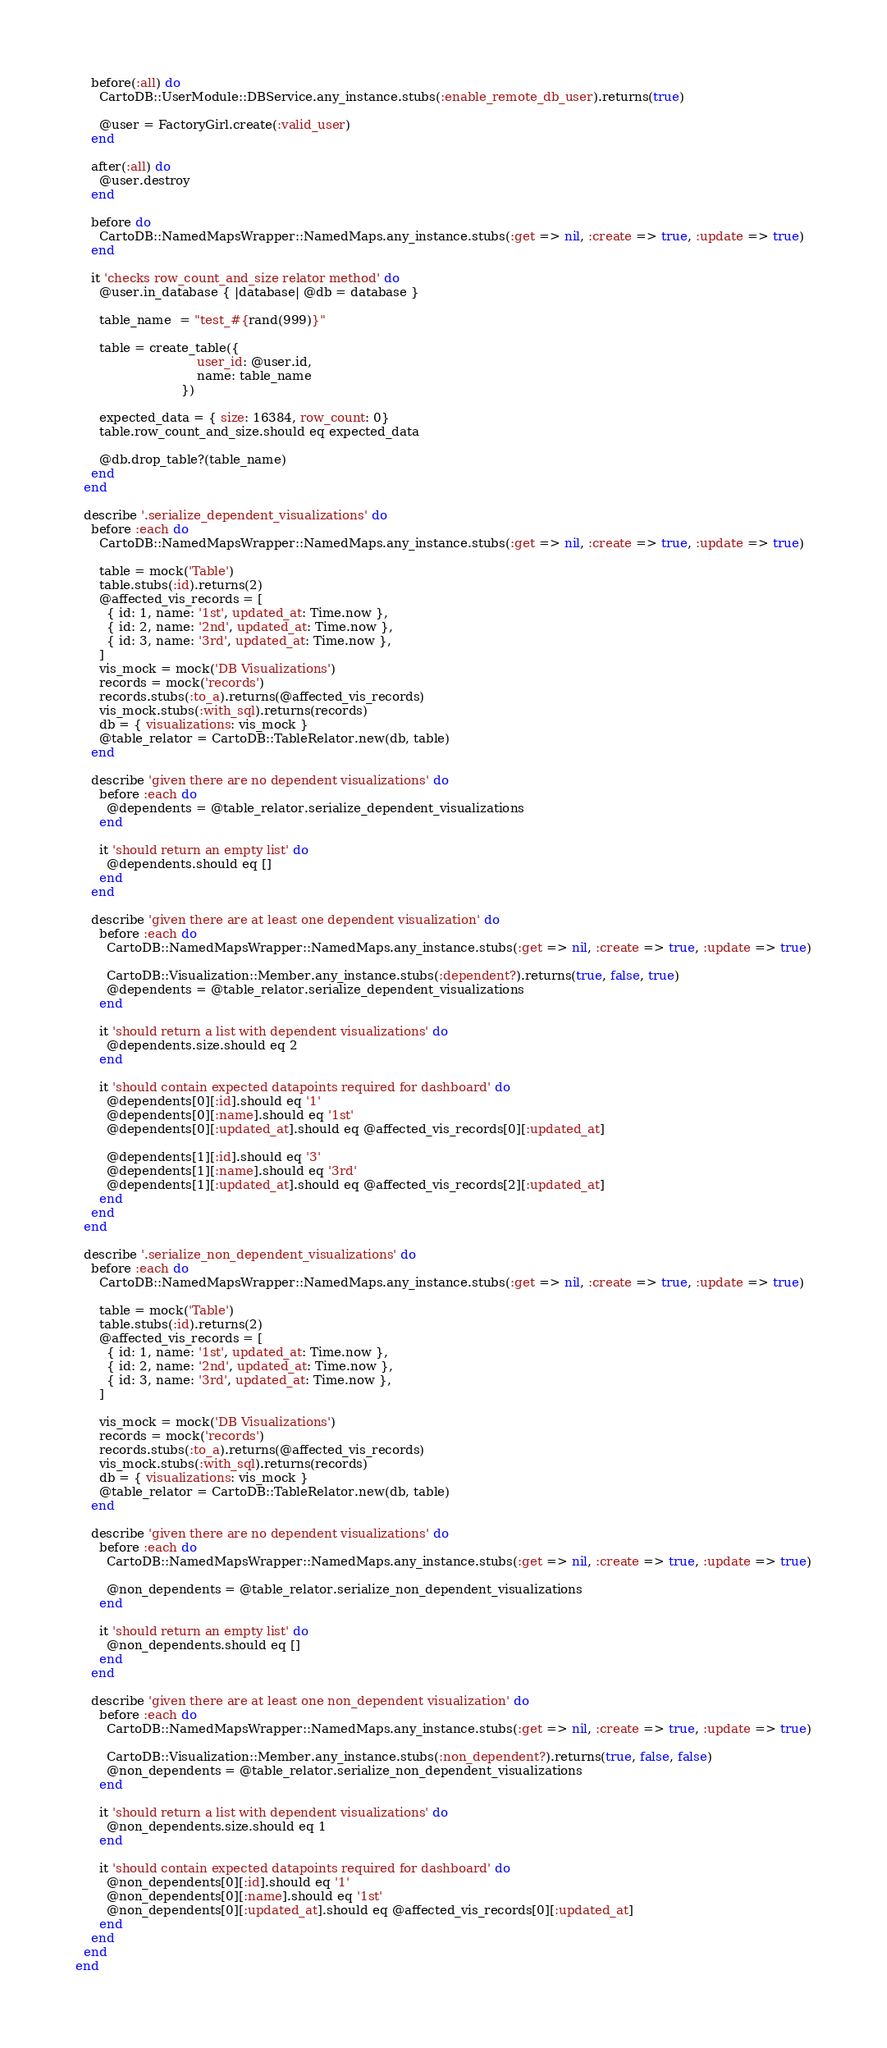Convert code to text. <code><loc_0><loc_0><loc_500><loc_500><_Ruby_>    before(:all) do
      CartoDB::UserModule::DBService.any_instance.stubs(:enable_remote_db_user).returns(true)

      @user = FactoryGirl.create(:valid_user)
    end

    after(:all) do
      @user.destroy
    end

    before do
      CartoDB::NamedMapsWrapper::NamedMaps.any_instance.stubs(:get => nil, :create => true, :update => true)
    end

    it 'checks row_count_and_size relator method' do
      @user.in_database { |database| @db = database }

      table_name  = "test_#{rand(999)}"

      table = create_table({
                               user_id: @user.id,
                               name: table_name
                           })

      expected_data = { size: 16384, row_count: 0}
      table.row_count_and_size.should eq expected_data

      @db.drop_table?(table_name)
    end
  end

  describe '.serialize_dependent_visualizations' do
    before :each do
      CartoDB::NamedMapsWrapper::NamedMaps.any_instance.stubs(:get => nil, :create => true, :update => true)

      table = mock('Table')
      table.stubs(:id).returns(2)
      @affected_vis_records = [
        { id: 1, name: '1st', updated_at: Time.now },
        { id: 2, name: '2nd', updated_at: Time.now },
        { id: 3, name: '3rd', updated_at: Time.now },
      ]
      vis_mock = mock('DB Visualizations')
      records = mock('records')
      records.stubs(:to_a).returns(@affected_vis_records)
      vis_mock.stubs(:with_sql).returns(records)
      db = { visualizations: vis_mock }
      @table_relator = CartoDB::TableRelator.new(db, table)
    end

    describe 'given there are no dependent visualizations' do
      before :each do
        @dependents = @table_relator.serialize_dependent_visualizations
      end

      it 'should return an empty list' do
        @dependents.should eq []
      end
    end

    describe 'given there are at least one dependent visualization' do
      before :each do
        CartoDB::NamedMapsWrapper::NamedMaps.any_instance.stubs(:get => nil, :create => true, :update => true)

        CartoDB::Visualization::Member.any_instance.stubs(:dependent?).returns(true, false, true)
        @dependents = @table_relator.serialize_dependent_visualizations
      end

      it 'should return a list with dependent visualizations' do
        @dependents.size.should eq 2
      end

      it 'should contain expected datapoints required for dashboard' do
        @dependents[0][:id].should eq '1'
        @dependents[0][:name].should eq '1st'
        @dependents[0][:updated_at].should eq @affected_vis_records[0][:updated_at]

        @dependents[1][:id].should eq '3'
        @dependents[1][:name].should eq '3rd'
        @dependents[1][:updated_at].should eq @affected_vis_records[2][:updated_at]
      end
    end
  end

  describe '.serialize_non_dependent_visualizations' do
    before :each do
      CartoDB::NamedMapsWrapper::NamedMaps.any_instance.stubs(:get => nil, :create => true, :update => true)

      table = mock('Table')
      table.stubs(:id).returns(2)
      @affected_vis_records = [
        { id: 1, name: '1st', updated_at: Time.now },
        { id: 2, name: '2nd', updated_at: Time.now },
        { id: 3, name: '3rd', updated_at: Time.now },
      ]

      vis_mock = mock('DB Visualizations')
      records = mock('records')
      records.stubs(:to_a).returns(@affected_vis_records)
      vis_mock.stubs(:with_sql).returns(records)
      db = { visualizations: vis_mock }
      @table_relator = CartoDB::TableRelator.new(db, table)
    end

    describe 'given there are no dependent visualizations' do
      before :each do
        CartoDB::NamedMapsWrapper::NamedMaps.any_instance.stubs(:get => nil, :create => true, :update => true)

        @non_dependents = @table_relator.serialize_non_dependent_visualizations
      end

      it 'should return an empty list' do
        @non_dependents.should eq []
      end
    end

    describe 'given there are at least one non_dependent visualization' do
      before :each do
        CartoDB::NamedMapsWrapper::NamedMaps.any_instance.stubs(:get => nil, :create => true, :update => true)

        CartoDB::Visualization::Member.any_instance.stubs(:non_dependent?).returns(true, false, false)
        @non_dependents = @table_relator.serialize_non_dependent_visualizations
      end

      it 'should return a list with dependent visualizations' do
        @non_dependents.size.should eq 1
      end

      it 'should contain expected datapoints required for dashboard' do
        @non_dependents[0][:id].should eq '1'
        @non_dependents[0][:name].should eq '1st'
        @non_dependents[0][:updated_at].should eq @affected_vis_records[0][:updated_at]
      end
    end
  end
end
</code> 